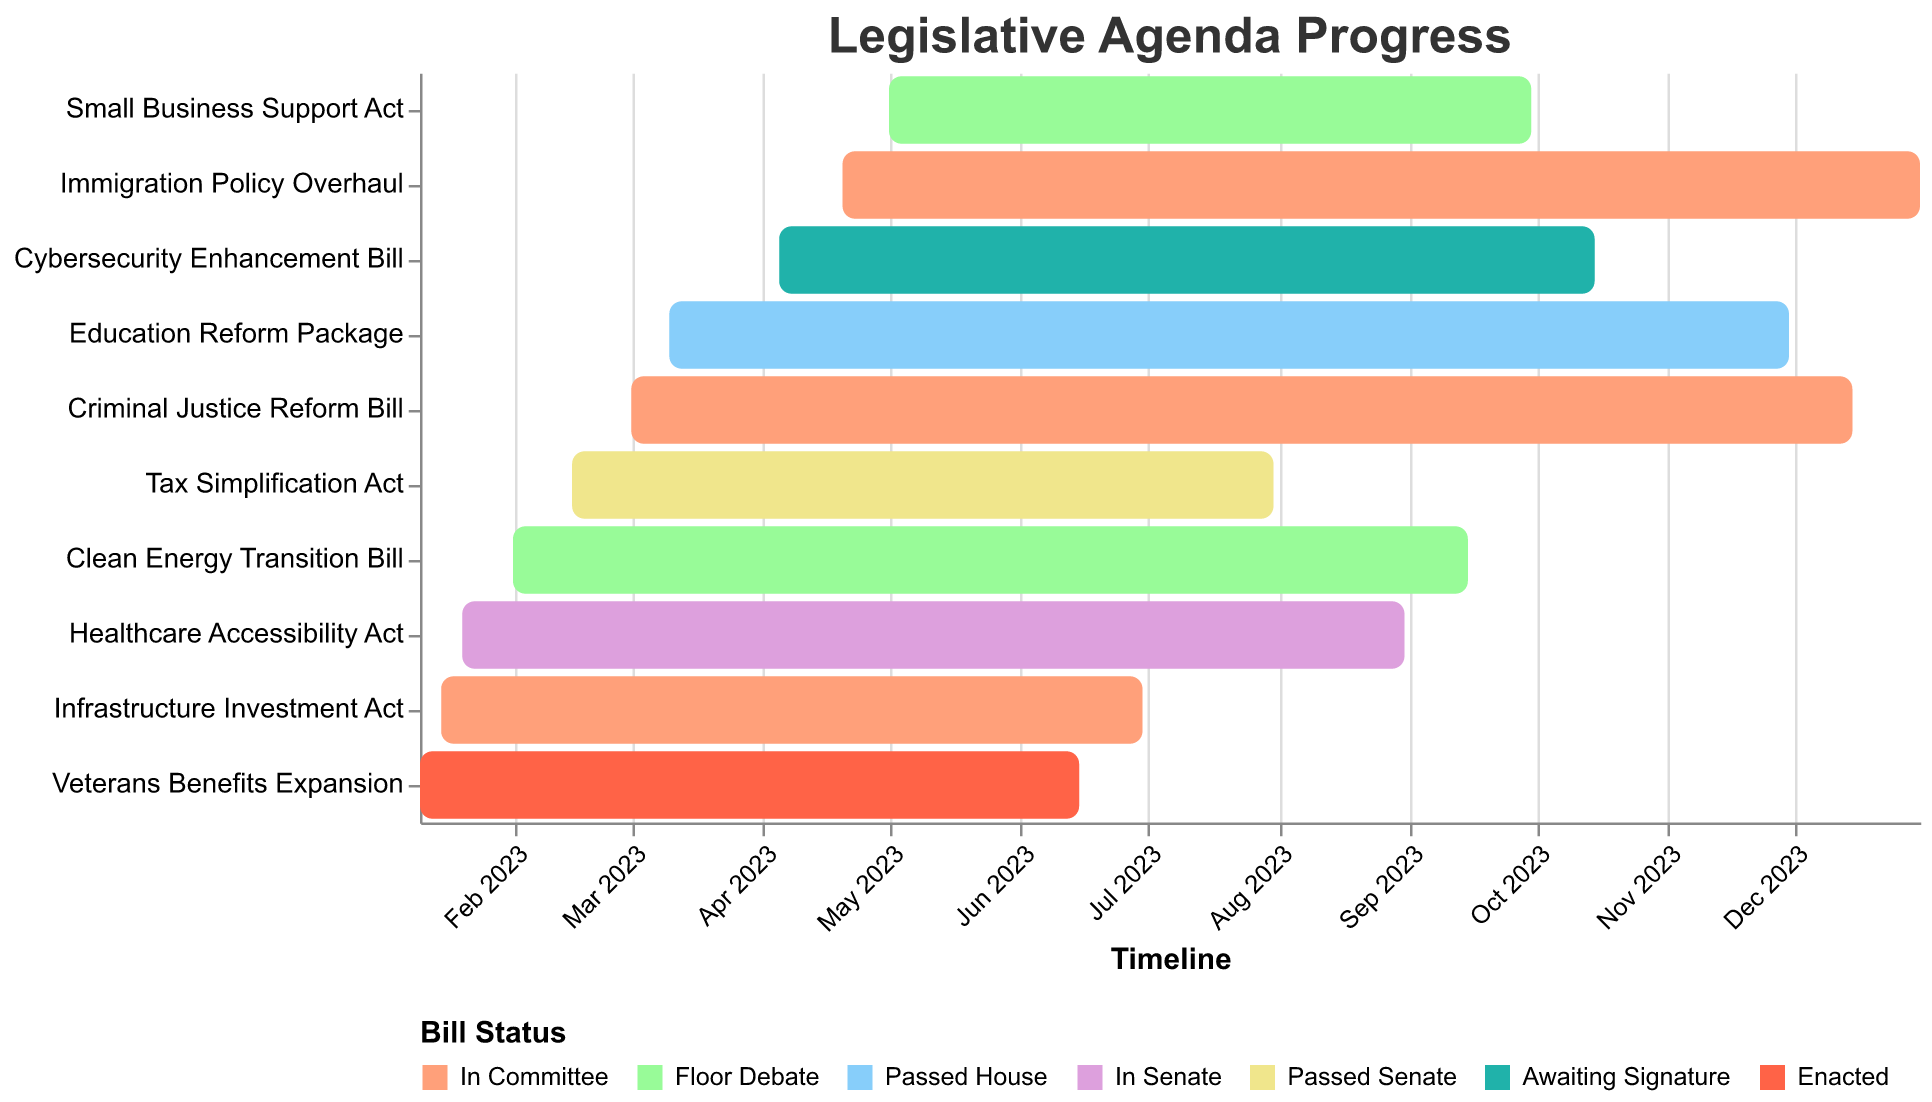What is the title of the figure? The title of the figure is noted at the top, displayed clearly in a larger font size. It typically describes the main subject of the visualization.
Answer: Legislative Agenda Progress Which bill is in the "Floor Debate" stage? Look for bars that are colored with the same hue as "Floor Debate" in the chart's legend. There are two such bars, representing the "Clean Energy Transition Bill" and "Small Business Support Act".
Answer: Clean Energy Transition Bill and Small Business Support Act How many bills are currently in the "In Committee" stage? Counting the bars colored with "In Committee" according to the legend will provide the answer. There are bars for "Infrastructure Investment Act", "Criminal Justice Reform Bill" and "Immigration Policy Overhaul".
Answer: 3 When does the "Tax Simplification Act" end? Find the bar corresponding to the "Tax Simplification Act" in the chart. The end date is listed at the end of the bar.
Answer: July 31, 2023 Which bill has the longest duration from start to end? Compare the length of the bars visually; the one stretching the furthest horizontally has the longest duration. "Education Reform Package" starts on March 10, 2023, and ends on November 30, 2023.
Answer: Education Reform Package Which bills have already been passed or enacted? Check the chart for bars that are colored as "Passed House", "Passed Senate", or "Enacted" according to the legend. These are "Education Reform Package", "Tax Simplification Act", and "Veterans Benefits Expansion".
Answer: Education Reform Package, Tax Simplification Act, and Veterans Benefits Expansion What is the total number of months that "Clean Energy Transition Bill" is under debate? Calculate the difference between the start and end date of "Clean Energy Transition Bill". From February 1, 2023, to September 15, 2023, is a span of 7 months and 14 days.
Answer: 7.5 months Which bill started the earliest? Identify the bar that begins furthest to the left. The "Veterans Benefits Expansion" started on January 10, 2023.
Answer: Veterans Benefits Expansion How many bills are in the "In Senate" stage? Look for bars colored according to the "In Senate" color in the legend. There is only one, which is the "Healthcare Accessibility Act".
Answer: 1 How does the duration of "Infrastructure Investment Act" compare with "Clean Energy Transition Bill"? Calculate the durations for both bills. "Infrastructure Investment Act" spans from January 15, 2023, to June 30, 2023, approximately 5.5 months. "Clean Energy Transition Bill" spans from February 1, 2023, to September 15, 2023, approximately 7.5 months. The "Clean Energy Transition Bill" is therefore longer by about 2 months.
Answer: Clean Energy Transition Bill is longer by 2 months 